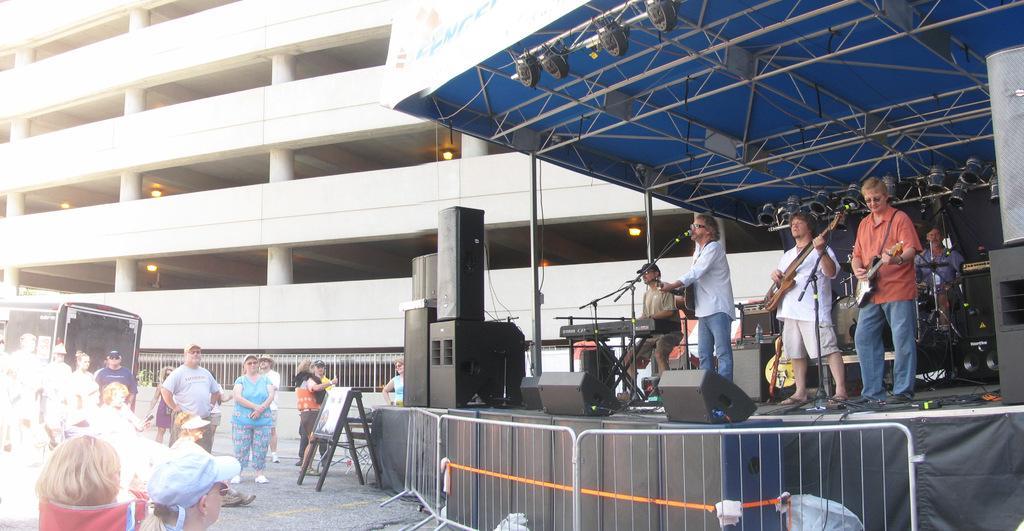Describe this image in one or two sentences. In this image we can see a group of people standing on the ground. On the right side of the image we can see group of people standing on stage. One person is sitting in front of keyboard placed on a stand. three persons are holding guitars. In the background, we can see group of musical instruments, lights, poles, speakers, shed and a building with some lights. In the foreground we can see metal barricade and a sign board. 